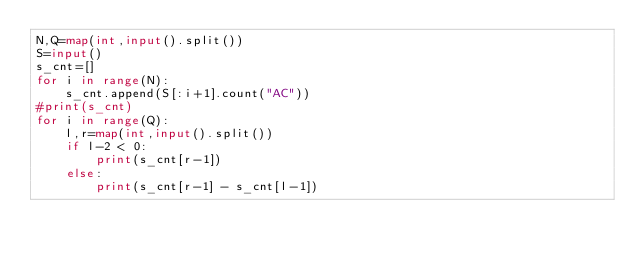Convert code to text. <code><loc_0><loc_0><loc_500><loc_500><_Python_>N,Q=map(int,input().split())
S=input()
s_cnt=[]
for i in range(N):
    s_cnt.append(S[:i+1].count("AC"))
#print(s_cnt)    
for i in range(Q):
    l,r=map(int,input().split())
    if l-2 < 0:
        print(s_cnt[r-1])
    else:    
        print(s_cnt[r-1] - s_cnt[l-1])</code> 